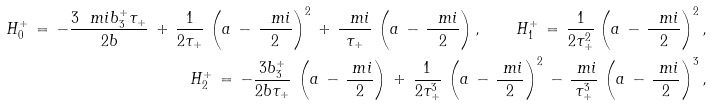Convert formula to latex. <formula><loc_0><loc_0><loc_500><loc_500>H _ { 0 } ^ { + } \, = \, - \frac { 3 \ m i b _ { 3 } ^ { + } \tau _ { + } } { 2 b } \, + \, \frac { 1 } { 2 \tau _ { + } } \, \left ( a \, - \, \frac { \ m i } { 2 } \right ) ^ { 2 } \, + \, \frac { \ m i } { \tau _ { + } } \, \left ( a \, - \, \frac { \ m i } { 2 } \right ) , \quad H _ { 1 } ^ { + } \, = \, \frac { 1 } { 2 \tau _ { + } ^ { 2 } } \left ( a \, - \, \frac { \ m i } { 2 } \right ) ^ { 2 } , \\ H _ { 2 } ^ { + } \, = \, - \frac { 3 b _ { 3 } ^ { + } } { 2 b \tau _ { + } } \, \left ( a \, - \, \frac { \ m i } { 2 } \right ) \, + \, \frac { 1 } { 2 \tau _ { + } ^ { 3 } } \, \left ( a \, - \, \frac { \ m i } { 2 } \right ) ^ { 2 } \, - \, \frac { \ m i } { \tau _ { + } ^ { 3 } } \, \left ( a \, - \, \frac { \ m i } { 2 } \right ) ^ { 3 } ,</formula> 